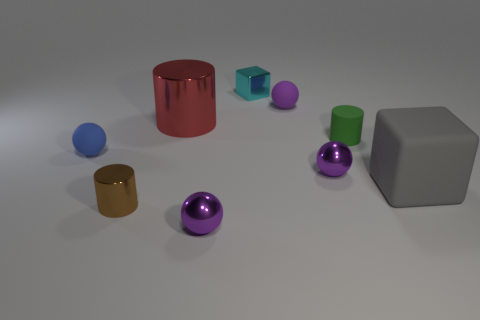The green rubber object that is the same size as the brown metallic cylinder is what shape? cylinder 